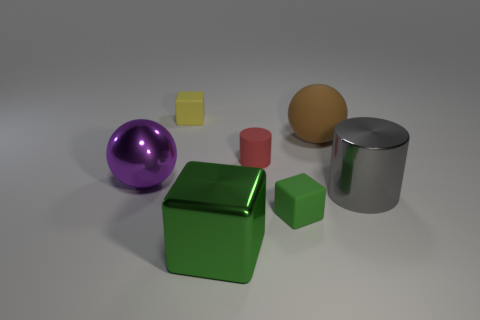What is the color of the cylinder on the left side of the rubber cube that is to the right of the small matte cylinder?
Your response must be concise. Red. Is the color of the big cube the same as the rubber block in front of the brown object?
Offer a terse response. Yes. There is a rubber thing that is on the right side of the small matte cube that is in front of the large gray shiny thing; how many big metallic objects are right of it?
Provide a short and direct response. 1. Are there any metallic spheres right of the yellow block?
Your answer should be compact. No. Is there any other thing that has the same color as the matte cylinder?
Make the answer very short. No. What number of cylinders are either big shiny objects or tiny green objects?
Your response must be concise. 1. How many spheres are both in front of the red matte object and to the right of the yellow thing?
Your response must be concise. 0. Are there an equal number of large things that are in front of the green metal cube and tiny yellow objects to the right of the brown ball?
Offer a terse response. Yes. Does the object that is right of the big brown thing have the same shape as the tiny yellow rubber object?
Give a very brief answer. No. There is a large shiny object that is to the left of the big metal thing that is in front of the rubber cube right of the large metal cube; what shape is it?
Ensure brevity in your answer.  Sphere. 